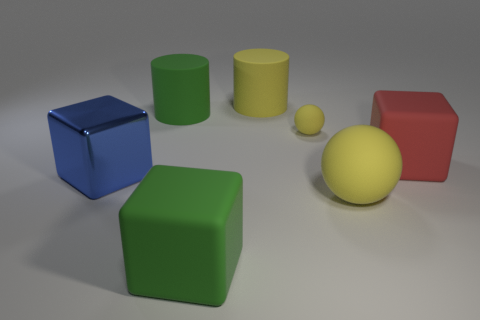Is the color of the tiny rubber thing the same as the big ball?
Offer a very short reply. Yes. There is a small matte object; what shape is it?
Your answer should be very brief. Sphere. Are there more big cylinders that are left of the yellow cylinder than big rubber cylinders in front of the large yellow rubber sphere?
Ensure brevity in your answer.  Yes. Does the ball that is in front of the large red object have the same color as the matte sphere that is behind the big red block?
Offer a terse response. Yes. What shape is the red thing that is the same size as the yellow matte cylinder?
Ensure brevity in your answer.  Cube. Are there any large red things that have the same shape as the blue object?
Provide a short and direct response. Yes. Do the sphere that is in front of the blue metal object and the yellow thing left of the small yellow ball have the same material?
Your answer should be very brief. Yes. There is a large rubber thing that is the same color as the big ball; what shape is it?
Make the answer very short. Cylinder. How many objects are the same material as the small ball?
Ensure brevity in your answer.  5. What is the color of the small matte ball?
Offer a terse response. Yellow. 